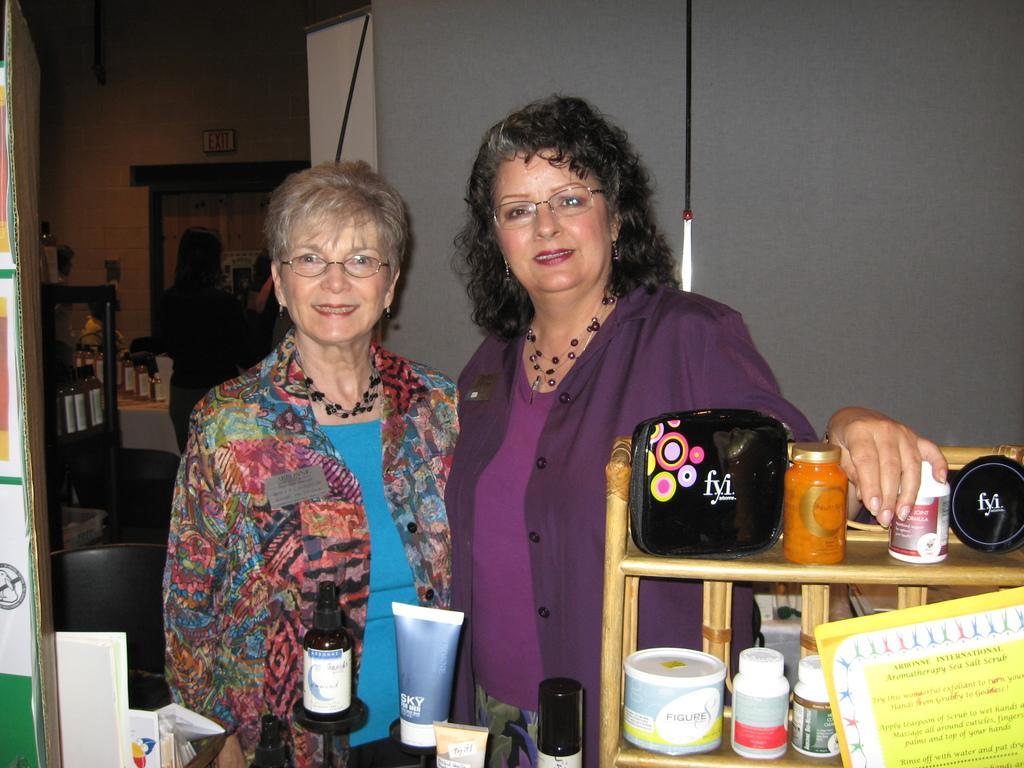Could you give a brief overview of what you see in this image? In the image there are two women and around the women there are different types of cosmetics, both the women are standing and posing for the photo and behind them there is another woman standing in front of the mirror. 